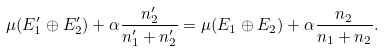Convert formula to latex. <formula><loc_0><loc_0><loc_500><loc_500>\mu ( E ^ { \prime } _ { 1 } \oplus E ^ { \prime } _ { 2 } ) + \alpha \frac { n ^ { \prime } _ { 2 } } { n _ { 1 } ^ { \prime } + n _ { 2 } ^ { \prime } } = \mu ( E _ { 1 } \oplus E _ { 2 } ) + \alpha \frac { n _ { 2 } } { n _ { 1 } + n _ { 2 } } .</formula> 